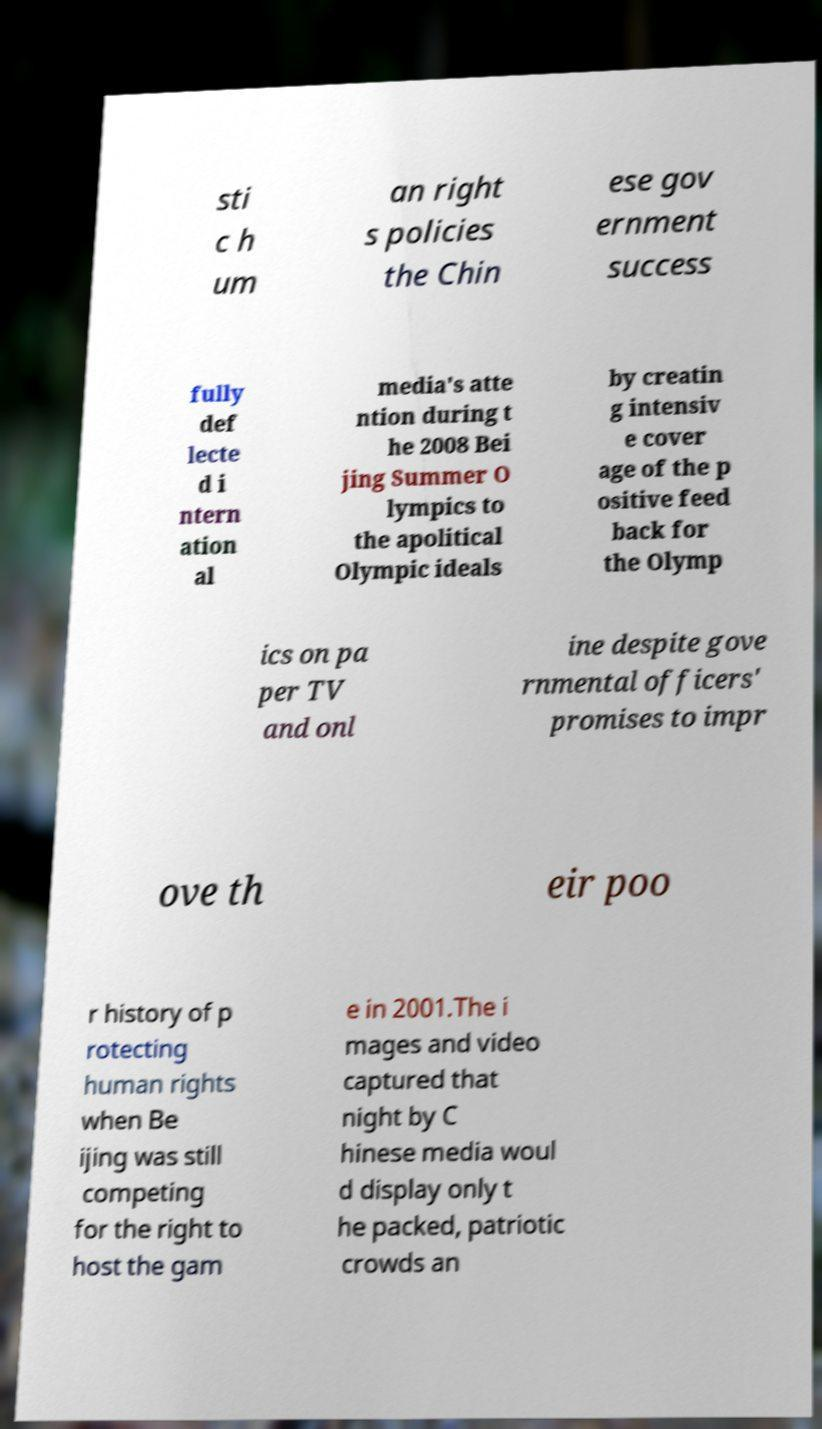There's text embedded in this image that I need extracted. Can you transcribe it verbatim? sti c h um an right s policies the Chin ese gov ernment success fully def lecte d i ntern ation al media's atte ntion during t he 2008 Bei jing Summer O lympics to the apolitical Olympic ideals by creatin g intensiv e cover age of the p ositive feed back for the Olymp ics on pa per TV and onl ine despite gove rnmental officers' promises to impr ove th eir poo r history of p rotecting human rights when Be ijing was still competing for the right to host the gam e in 2001.The i mages and video captured that night by C hinese media woul d display only t he packed, patriotic crowds an 